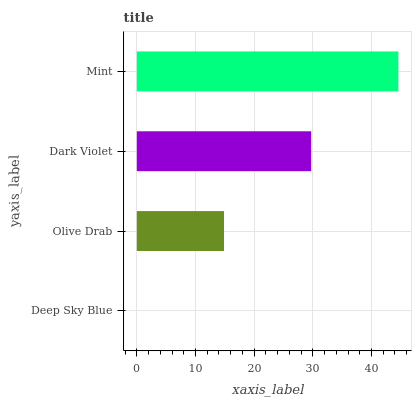Is Deep Sky Blue the minimum?
Answer yes or no. Yes. Is Mint the maximum?
Answer yes or no. Yes. Is Olive Drab the minimum?
Answer yes or no. No. Is Olive Drab the maximum?
Answer yes or no. No. Is Olive Drab greater than Deep Sky Blue?
Answer yes or no. Yes. Is Deep Sky Blue less than Olive Drab?
Answer yes or no. Yes. Is Deep Sky Blue greater than Olive Drab?
Answer yes or no. No. Is Olive Drab less than Deep Sky Blue?
Answer yes or no. No. Is Dark Violet the high median?
Answer yes or no. Yes. Is Olive Drab the low median?
Answer yes or no. Yes. Is Mint the high median?
Answer yes or no. No. Is Dark Violet the low median?
Answer yes or no. No. 